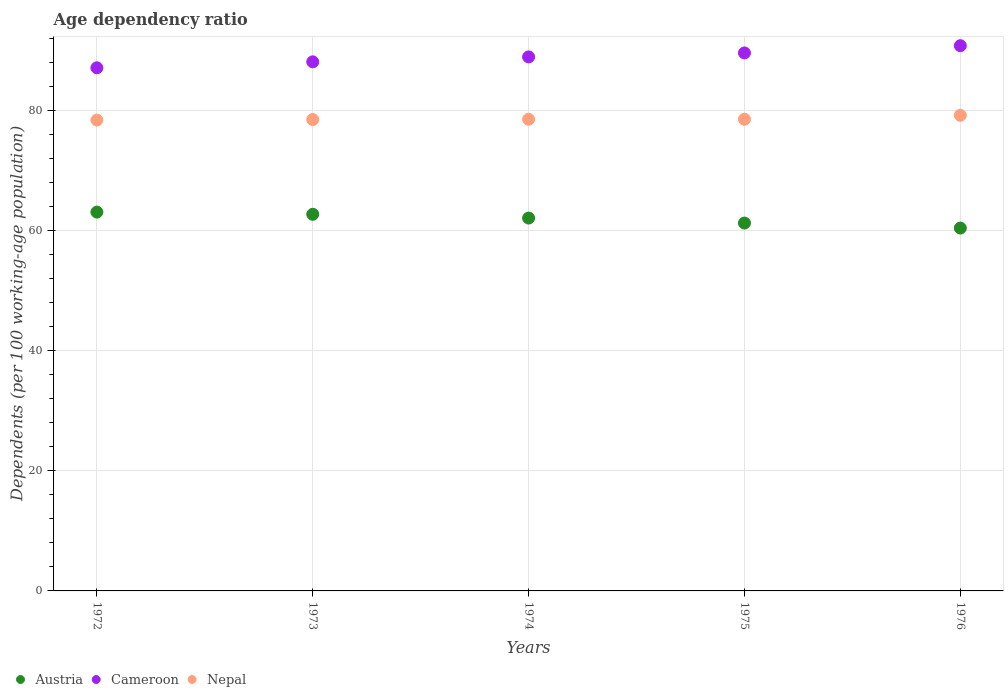How many different coloured dotlines are there?
Offer a terse response. 3. What is the age dependency ratio in in Cameroon in 1972?
Provide a short and direct response. 87.17. Across all years, what is the maximum age dependency ratio in in Cameroon?
Your answer should be compact. 90.85. Across all years, what is the minimum age dependency ratio in in Cameroon?
Your answer should be very brief. 87.17. In which year was the age dependency ratio in in Austria minimum?
Provide a succinct answer. 1976. What is the total age dependency ratio in in Austria in the graph?
Provide a succinct answer. 309.78. What is the difference between the age dependency ratio in in Austria in 1974 and that in 1976?
Offer a terse response. 1.66. What is the difference between the age dependency ratio in in Nepal in 1975 and the age dependency ratio in in Cameroon in 1976?
Provide a short and direct response. -12.25. What is the average age dependency ratio in in Nepal per year?
Provide a succinct answer. 78.69. In the year 1975, what is the difference between the age dependency ratio in in Austria and age dependency ratio in in Nepal?
Give a very brief answer. -17.3. In how many years, is the age dependency ratio in in Cameroon greater than 76 %?
Your response must be concise. 5. What is the ratio of the age dependency ratio in in Cameroon in 1974 to that in 1975?
Provide a succinct answer. 0.99. Is the age dependency ratio in in Cameroon in 1972 less than that in 1974?
Give a very brief answer. Yes. What is the difference between the highest and the second highest age dependency ratio in in Austria?
Your response must be concise. 0.36. What is the difference between the highest and the lowest age dependency ratio in in Austria?
Provide a short and direct response. 2.66. Is it the case that in every year, the sum of the age dependency ratio in in Cameroon and age dependency ratio in in Austria  is greater than the age dependency ratio in in Nepal?
Give a very brief answer. Yes. Is the age dependency ratio in in Cameroon strictly less than the age dependency ratio in in Nepal over the years?
Give a very brief answer. No. How many years are there in the graph?
Provide a succinct answer. 5. What is the difference between two consecutive major ticks on the Y-axis?
Make the answer very short. 20. Are the values on the major ticks of Y-axis written in scientific E-notation?
Offer a very short reply. No. Where does the legend appear in the graph?
Keep it short and to the point. Bottom left. How many legend labels are there?
Provide a short and direct response. 3. How are the legend labels stacked?
Offer a terse response. Horizontal. What is the title of the graph?
Your answer should be compact. Age dependency ratio. What is the label or title of the X-axis?
Your answer should be compact. Years. What is the label or title of the Y-axis?
Your answer should be very brief. Dependents (per 100 working-age population). What is the Dependents (per 100 working-age population) of Austria in 1972?
Offer a very short reply. 63.12. What is the Dependents (per 100 working-age population) of Cameroon in 1972?
Offer a terse response. 87.17. What is the Dependents (per 100 working-age population) of Nepal in 1972?
Ensure brevity in your answer.  78.46. What is the Dependents (per 100 working-age population) of Austria in 1973?
Provide a succinct answer. 62.76. What is the Dependents (per 100 working-age population) in Cameroon in 1973?
Your answer should be very brief. 88.16. What is the Dependents (per 100 working-age population) of Nepal in 1973?
Make the answer very short. 78.55. What is the Dependents (per 100 working-age population) in Austria in 1974?
Keep it short and to the point. 62.13. What is the Dependents (per 100 working-age population) of Cameroon in 1974?
Your response must be concise. 88.99. What is the Dependents (per 100 working-age population) in Nepal in 1974?
Your answer should be very brief. 78.6. What is the Dependents (per 100 working-age population) in Austria in 1975?
Offer a very short reply. 61.3. What is the Dependents (per 100 working-age population) in Cameroon in 1975?
Your answer should be compact. 89.65. What is the Dependents (per 100 working-age population) in Nepal in 1975?
Your response must be concise. 78.6. What is the Dependents (per 100 working-age population) of Austria in 1976?
Keep it short and to the point. 60.47. What is the Dependents (per 100 working-age population) in Cameroon in 1976?
Ensure brevity in your answer.  90.85. What is the Dependents (per 100 working-age population) in Nepal in 1976?
Make the answer very short. 79.25. Across all years, what is the maximum Dependents (per 100 working-age population) of Austria?
Your response must be concise. 63.12. Across all years, what is the maximum Dependents (per 100 working-age population) in Cameroon?
Provide a short and direct response. 90.85. Across all years, what is the maximum Dependents (per 100 working-age population) in Nepal?
Provide a short and direct response. 79.25. Across all years, what is the minimum Dependents (per 100 working-age population) in Austria?
Your response must be concise. 60.47. Across all years, what is the minimum Dependents (per 100 working-age population) in Cameroon?
Make the answer very short. 87.17. Across all years, what is the minimum Dependents (per 100 working-age population) of Nepal?
Make the answer very short. 78.46. What is the total Dependents (per 100 working-age population) in Austria in the graph?
Your answer should be compact. 309.78. What is the total Dependents (per 100 working-age population) of Cameroon in the graph?
Provide a succinct answer. 444.82. What is the total Dependents (per 100 working-age population) of Nepal in the graph?
Your response must be concise. 393.46. What is the difference between the Dependents (per 100 working-age population) in Austria in 1972 and that in 1973?
Offer a very short reply. 0.36. What is the difference between the Dependents (per 100 working-age population) of Cameroon in 1972 and that in 1973?
Give a very brief answer. -0.99. What is the difference between the Dependents (per 100 working-age population) of Nepal in 1972 and that in 1973?
Give a very brief answer. -0.09. What is the difference between the Dependents (per 100 working-age population) in Austria in 1972 and that in 1974?
Keep it short and to the point. 0.99. What is the difference between the Dependents (per 100 working-age population) of Cameroon in 1972 and that in 1974?
Keep it short and to the point. -1.82. What is the difference between the Dependents (per 100 working-age population) in Nepal in 1972 and that in 1974?
Give a very brief answer. -0.14. What is the difference between the Dependents (per 100 working-age population) in Austria in 1972 and that in 1975?
Offer a very short reply. 1.83. What is the difference between the Dependents (per 100 working-age population) of Cameroon in 1972 and that in 1975?
Keep it short and to the point. -2.48. What is the difference between the Dependents (per 100 working-age population) in Nepal in 1972 and that in 1975?
Provide a short and direct response. -0.14. What is the difference between the Dependents (per 100 working-age population) of Austria in 1972 and that in 1976?
Provide a succinct answer. 2.66. What is the difference between the Dependents (per 100 working-age population) in Cameroon in 1972 and that in 1976?
Your response must be concise. -3.68. What is the difference between the Dependents (per 100 working-age population) of Nepal in 1972 and that in 1976?
Your response must be concise. -0.79. What is the difference between the Dependents (per 100 working-age population) of Austria in 1973 and that in 1974?
Offer a very short reply. 0.63. What is the difference between the Dependents (per 100 working-age population) of Cameroon in 1973 and that in 1974?
Provide a short and direct response. -0.82. What is the difference between the Dependents (per 100 working-age population) in Nepal in 1973 and that in 1974?
Ensure brevity in your answer.  -0.05. What is the difference between the Dependents (per 100 working-age population) of Austria in 1973 and that in 1975?
Offer a very short reply. 1.46. What is the difference between the Dependents (per 100 working-age population) of Cameroon in 1973 and that in 1975?
Provide a short and direct response. -1.48. What is the difference between the Dependents (per 100 working-age population) of Nepal in 1973 and that in 1975?
Offer a very short reply. -0.05. What is the difference between the Dependents (per 100 working-age population) of Austria in 1973 and that in 1976?
Keep it short and to the point. 2.29. What is the difference between the Dependents (per 100 working-age population) in Cameroon in 1973 and that in 1976?
Make the answer very short. -2.69. What is the difference between the Dependents (per 100 working-age population) in Nepal in 1973 and that in 1976?
Your response must be concise. -0.7. What is the difference between the Dependents (per 100 working-age population) of Austria in 1974 and that in 1975?
Give a very brief answer. 0.83. What is the difference between the Dependents (per 100 working-age population) in Cameroon in 1974 and that in 1975?
Offer a very short reply. -0.66. What is the difference between the Dependents (per 100 working-age population) of Nepal in 1974 and that in 1975?
Give a very brief answer. -0.01. What is the difference between the Dependents (per 100 working-age population) of Austria in 1974 and that in 1976?
Keep it short and to the point. 1.66. What is the difference between the Dependents (per 100 working-age population) of Cameroon in 1974 and that in 1976?
Keep it short and to the point. -1.87. What is the difference between the Dependents (per 100 working-age population) of Nepal in 1974 and that in 1976?
Provide a short and direct response. -0.66. What is the difference between the Dependents (per 100 working-age population) in Austria in 1975 and that in 1976?
Your response must be concise. 0.83. What is the difference between the Dependents (per 100 working-age population) of Cameroon in 1975 and that in 1976?
Keep it short and to the point. -1.21. What is the difference between the Dependents (per 100 working-age population) in Nepal in 1975 and that in 1976?
Offer a very short reply. -0.65. What is the difference between the Dependents (per 100 working-age population) of Austria in 1972 and the Dependents (per 100 working-age population) of Cameroon in 1973?
Offer a terse response. -25.04. What is the difference between the Dependents (per 100 working-age population) in Austria in 1972 and the Dependents (per 100 working-age population) in Nepal in 1973?
Provide a short and direct response. -15.43. What is the difference between the Dependents (per 100 working-age population) of Cameroon in 1972 and the Dependents (per 100 working-age population) of Nepal in 1973?
Provide a short and direct response. 8.62. What is the difference between the Dependents (per 100 working-age population) in Austria in 1972 and the Dependents (per 100 working-age population) in Cameroon in 1974?
Offer a very short reply. -25.86. What is the difference between the Dependents (per 100 working-age population) of Austria in 1972 and the Dependents (per 100 working-age population) of Nepal in 1974?
Keep it short and to the point. -15.47. What is the difference between the Dependents (per 100 working-age population) of Cameroon in 1972 and the Dependents (per 100 working-age population) of Nepal in 1974?
Provide a short and direct response. 8.58. What is the difference between the Dependents (per 100 working-age population) in Austria in 1972 and the Dependents (per 100 working-age population) in Cameroon in 1975?
Make the answer very short. -26.52. What is the difference between the Dependents (per 100 working-age population) of Austria in 1972 and the Dependents (per 100 working-age population) of Nepal in 1975?
Your response must be concise. -15.48. What is the difference between the Dependents (per 100 working-age population) in Cameroon in 1972 and the Dependents (per 100 working-age population) in Nepal in 1975?
Give a very brief answer. 8.57. What is the difference between the Dependents (per 100 working-age population) of Austria in 1972 and the Dependents (per 100 working-age population) of Cameroon in 1976?
Ensure brevity in your answer.  -27.73. What is the difference between the Dependents (per 100 working-age population) of Austria in 1972 and the Dependents (per 100 working-age population) of Nepal in 1976?
Provide a short and direct response. -16.13. What is the difference between the Dependents (per 100 working-age population) of Cameroon in 1972 and the Dependents (per 100 working-age population) of Nepal in 1976?
Provide a short and direct response. 7.92. What is the difference between the Dependents (per 100 working-age population) in Austria in 1973 and the Dependents (per 100 working-age population) in Cameroon in 1974?
Provide a short and direct response. -26.23. What is the difference between the Dependents (per 100 working-age population) of Austria in 1973 and the Dependents (per 100 working-age population) of Nepal in 1974?
Provide a short and direct response. -15.84. What is the difference between the Dependents (per 100 working-age population) of Cameroon in 1973 and the Dependents (per 100 working-age population) of Nepal in 1974?
Make the answer very short. 9.57. What is the difference between the Dependents (per 100 working-age population) in Austria in 1973 and the Dependents (per 100 working-age population) in Cameroon in 1975?
Offer a very short reply. -26.89. What is the difference between the Dependents (per 100 working-age population) of Austria in 1973 and the Dependents (per 100 working-age population) of Nepal in 1975?
Make the answer very short. -15.84. What is the difference between the Dependents (per 100 working-age population) of Cameroon in 1973 and the Dependents (per 100 working-age population) of Nepal in 1975?
Give a very brief answer. 9.56. What is the difference between the Dependents (per 100 working-age population) in Austria in 1973 and the Dependents (per 100 working-age population) in Cameroon in 1976?
Your response must be concise. -28.09. What is the difference between the Dependents (per 100 working-age population) of Austria in 1973 and the Dependents (per 100 working-age population) of Nepal in 1976?
Your answer should be very brief. -16.49. What is the difference between the Dependents (per 100 working-age population) in Cameroon in 1973 and the Dependents (per 100 working-age population) in Nepal in 1976?
Your answer should be compact. 8.91. What is the difference between the Dependents (per 100 working-age population) of Austria in 1974 and the Dependents (per 100 working-age population) of Cameroon in 1975?
Your answer should be compact. -27.52. What is the difference between the Dependents (per 100 working-age population) of Austria in 1974 and the Dependents (per 100 working-age population) of Nepal in 1975?
Give a very brief answer. -16.47. What is the difference between the Dependents (per 100 working-age population) of Cameroon in 1974 and the Dependents (per 100 working-age population) of Nepal in 1975?
Your answer should be compact. 10.39. What is the difference between the Dependents (per 100 working-age population) in Austria in 1974 and the Dependents (per 100 working-age population) in Cameroon in 1976?
Your answer should be very brief. -28.72. What is the difference between the Dependents (per 100 working-age population) of Austria in 1974 and the Dependents (per 100 working-age population) of Nepal in 1976?
Ensure brevity in your answer.  -17.12. What is the difference between the Dependents (per 100 working-age population) of Cameroon in 1974 and the Dependents (per 100 working-age population) of Nepal in 1976?
Provide a short and direct response. 9.74. What is the difference between the Dependents (per 100 working-age population) of Austria in 1975 and the Dependents (per 100 working-age population) of Cameroon in 1976?
Your answer should be very brief. -29.56. What is the difference between the Dependents (per 100 working-age population) of Austria in 1975 and the Dependents (per 100 working-age population) of Nepal in 1976?
Keep it short and to the point. -17.95. What is the difference between the Dependents (per 100 working-age population) in Cameroon in 1975 and the Dependents (per 100 working-age population) in Nepal in 1976?
Your answer should be compact. 10.39. What is the average Dependents (per 100 working-age population) in Austria per year?
Keep it short and to the point. 61.96. What is the average Dependents (per 100 working-age population) of Cameroon per year?
Provide a short and direct response. 88.96. What is the average Dependents (per 100 working-age population) of Nepal per year?
Offer a very short reply. 78.69. In the year 1972, what is the difference between the Dependents (per 100 working-age population) of Austria and Dependents (per 100 working-age population) of Cameroon?
Offer a very short reply. -24.05. In the year 1972, what is the difference between the Dependents (per 100 working-age population) of Austria and Dependents (per 100 working-age population) of Nepal?
Keep it short and to the point. -15.33. In the year 1972, what is the difference between the Dependents (per 100 working-age population) in Cameroon and Dependents (per 100 working-age population) in Nepal?
Make the answer very short. 8.71. In the year 1973, what is the difference between the Dependents (per 100 working-age population) of Austria and Dependents (per 100 working-age population) of Cameroon?
Keep it short and to the point. -25.4. In the year 1973, what is the difference between the Dependents (per 100 working-age population) in Austria and Dependents (per 100 working-age population) in Nepal?
Your response must be concise. -15.79. In the year 1973, what is the difference between the Dependents (per 100 working-age population) of Cameroon and Dependents (per 100 working-age population) of Nepal?
Offer a terse response. 9.61. In the year 1974, what is the difference between the Dependents (per 100 working-age population) of Austria and Dependents (per 100 working-age population) of Cameroon?
Provide a short and direct response. -26.86. In the year 1974, what is the difference between the Dependents (per 100 working-age population) of Austria and Dependents (per 100 working-age population) of Nepal?
Provide a short and direct response. -16.47. In the year 1974, what is the difference between the Dependents (per 100 working-age population) of Cameroon and Dependents (per 100 working-age population) of Nepal?
Your response must be concise. 10.39. In the year 1975, what is the difference between the Dependents (per 100 working-age population) in Austria and Dependents (per 100 working-age population) in Cameroon?
Your answer should be compact. -28.35. In the year 1975, what is the difference between the Dependents (per 100 working-age population) of Austria and Dependents (per 100 working-age population) of Nepal?
Offer a terse response. -17.3. In the year 1975, what is the difference between the Dependents (per 100 working-age population) in Cameroon and Dependents (per 100 working-age population) in Nepal?
Offer a terse response. 11.05. In the year 1976, what is the difference between the Dependents (per 100 working-age population) in Austria and Dependents (per 100 working-age population) in Cameroon?
Provide a short and direct response. -30.39. In the year 1976, what is the difference between the Dependents (per 100 working-age population) of Austria and Dependents (per 100 working-age population) of Nepal?
Offer a very short reply. -18.79. In the year 1976, what is the difference between the Dependents (per 100 working-age population) in Cameroon and Dependents (per 100 working-age population) in Nepal?
Offer a terse response. 11.6. What is the ratio of the Dependents (per 100 working-age population) in Cameroon in 1972 to that in 1973?
Ensure brevity in your answer.  0.99. What is the ratio of the Dependents (per 100 working-age population) in Cameroon in 1972 to that in 1974?
Offer a very short reply. 0.98. What is the ratio of the Dependents (per 100 working-age population) in Nepal in 1972 to that in 1974?
Your answer should be very brief. 1. What is the ratio of the Dependents (per 100 working-age population) in Austria in 1972 to that in 1975?
Ensure brevity in your answer.  1.03. What is the ratio of the Dependents (per 100 working-age population) in Cameroon in 1972 to that in 1975?
Your response must be concise. 0.97. What is the ratio of the Dependents (per 100 working-age population) of Nepal in 1972 to that in 1975?
Your answer should be very brief. 1. What is the ratio of the Dependents (per 100 working-age population) in Austria in 1972 to that in 1976?
Ensure brevity in your answer.  1.04. What is the ratio of the Dependents (per 100 working-age population) in Cameroon in 1972 to that in 1976?
Your response must be concise. 0.96. What is the ratio of the Dependents (per 100 working-age population) of Nepal in 1972 to that in 1976?
Your answer should be very brief. 0.99. What is the ratio of the Dependents (per 100 working-age population) in Austria in 1973 to that in 1974?
Keep it short and to the point. 1.01. What is the ratio of the Dependents (per 100 working-age population) of Nepal in 1973 to that in 1974?
Your response must be concise. 1. What is the ratio of the Dependents (per 100 working-age population) of Austria in 1973 to that in 1975?
Make the answer very short. 1.02. What is the ratio of the Dependents (per 100 working-age population) of Cameroon in 1973 to that in 1975?
Your answer should be compact. 0.98. What is the ratio of the Dependents (per 100 working-age population) in Austria in 1973 to that in 1976?
Make the answer very short. 1.04. What is the ratio of the Dependents (per 100 working-age population) of Cameroon in 1973 to that in 1976?
Offer a terse response. 0.97. What is the ratio of the Dependents (per 100 working-age population) in Nepal in 1973 to that in 1976?
Ensure brevity in your answer.  0.99. What is the ratio of the Dependents (per 100 working-age population) of Austria in 1974 to that in 1975?
Keep it short and to the point. 1.01. What is the ratio of the Dependents (per 100 working-age population) of Nepal in 1974 to that in 1975?
Your response must be concise. 1. What is the ratio of the Dependents (per 100 working-age population) of Austria in 1974 to that in 1976?
Offer a very short reply. 1.03. What is the ratio of the Dependents (per 100 working-age population) in Cameroon in 1974 to that in 1976?
Make the answer very short. 0.98. What is the ratio of the Dependents (per 100 working-age population) of Austria in 1975 to that in 1976?
Provide a short and direct response. 1.01. What is the ratio of the Dependents (per 100 working-age population) of Cameroon in 1975 to that in 1976?
Ensure brevity in your answer.  0.99. What is the ratio of the Dependents (per 100 working-age population) in Nepal in 1975 to that in 1976?
Provide a succinct answer. 0.99. What is the difference between the highest and the second highest Dependents (per 100 working-age population) of Austria?
Provide a succinct answer. 0.36. What is the difference between the highest and the second highest Dependents (per 100 working-age population) in Cameroon?
Your response must be concise. 1.21. What is the difference between the highest and the second highest Dependents (per 100 working-age population) of Nepal?
Offer a very short reply. 0.65. What is the difference between the highest and the lowest Dependents (per 100 working-age population) in Austria?
Your response must be concise. 2.66. What is the difference between the highest and the lowest Dependents (per 100 working-age population) in Cameroon?
Make the answer very short. 3.68. What is the difference between the highest and the lowest Dependents (per 100 working-age population) of Nepal?
Make the answer very short. 0.79. 